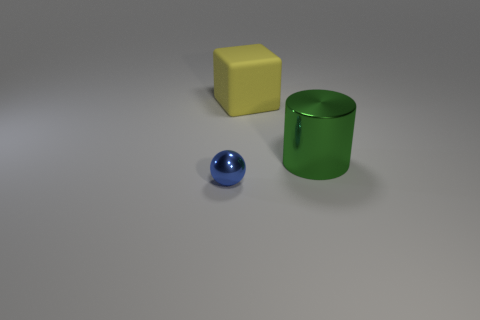Is there anything else that has the same material as the big yellow thing?
Offer a very short reply. No. What is the shape of the tiny metal thing that is in front of the large thing to the left of the shiny object behind the tiny blue object?
Make the answer very short. Sphere. Does the block have the same size as the shiny cylinder?
Ensure brevity in your answer.  Yes. What number of objects are either purple shiny spheres or objects that are on the left side of the green metallic cylinder?
Provide a short and direct response. 2. How many objects are either metallic things that are on the right side of the tiny blue thing or things left of the large green thing?
Your answer should be very brief. 3. Are there any yellow blocks on the right side of the metal sphere?
Offer a terse response. Yes. The big object to the right of the thing behind the metal thing that is right of the metal ball is what color?
Offer a terse response. Green. What is the color of the other thing that is the same material as the blue thing?
Offer a very short reply. Green. What number of things are things right of the tiny blue object or tiny metallic spheres?
Offer a very short reply. 3. There is a metal thing that is on the right side of the yellow rubber thing; what size is it?
Your response must be concise. Large. 